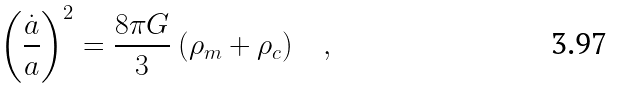Convert formula to latex. <formula><loc_0><loc_0><loc_500><loc_500>\left ( \frac { \dot { a } } { a } \right ) ^ { 2 } = \frac { 8 \pi G } { 3 } \ ( \rho _ { m } + \rho _ { c } ) \quad ,</formula> 